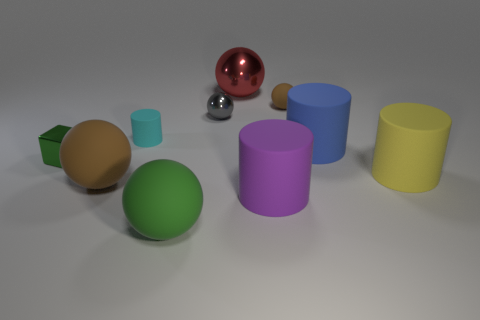Subtract all large rubber cylinders. How many cylinders are left? 1 Subtract all blue cylinders. How many brown spheres are left? 2 Subtract all yellow cylinders. How many cylinders are left? 3 Subtract 1 balls. How many balls are left? 4 Subtract all cylinders. How many objects are left? 6 Add 7 big balls. How many big balls are left? 10 Add 8 cyan matte objects. How many cyan matte objects exist? 9 Subtract 0 brown blocks. How many objects are left? 10 Subtract all gray spheres. Subtract all gray cylinders. How many spheres are left? 4 Subtract all big yellow rubber things. Subtract all green metallic cubes. How many objects are left? 8 